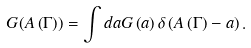<formula> <loc_0><loc_0><loc_500><loc_500>G ( A \left ( \Gamma \right ) ) = \int d a G \left ( a \right ) \delta \left ( A \left ( \Gamma \right ) - a \right ) .</formula> 